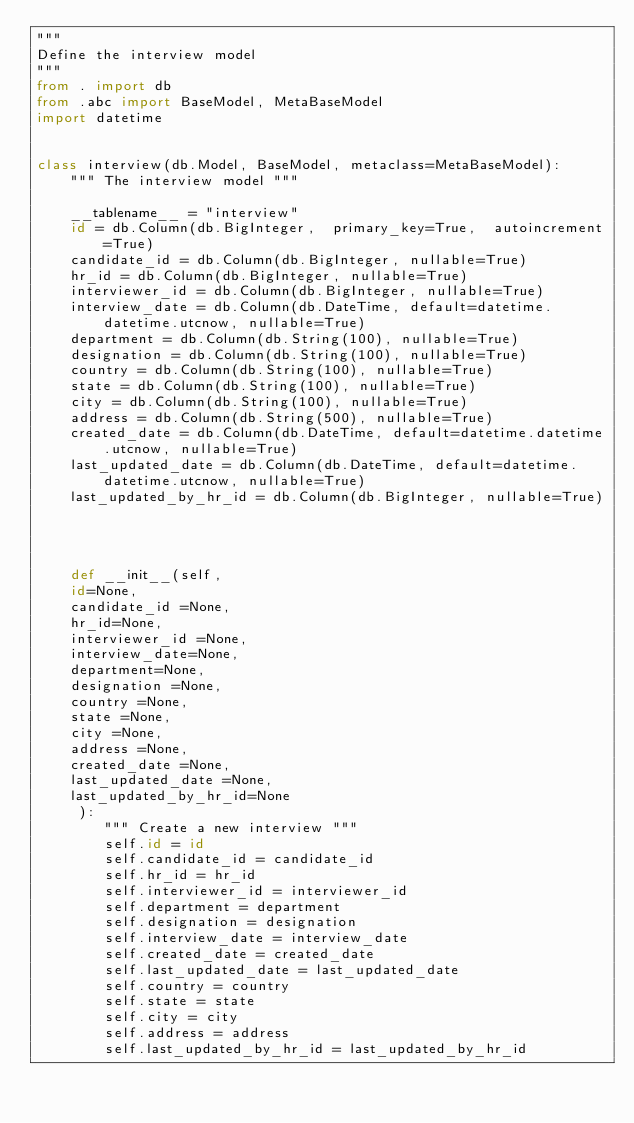Convert code to text. <code><loc_0><loc_0><loc_500><loc_500><_Python_>"""
Define the interview model
"""
from . import db
from .abc import BaseModel, MetaBaseModel
import datetime


class interview(db.Model, BaseModel, metaclass=MetaBaseModel):
    """ The interview model """

    __tablename__ = "interview"
    id = db.Column(db.BigInteger,  primary_key=True,  autoincrement=True)
    candidate_id = db.Column(db.BigInteger, nullable=True)
    hr_id = db.Column(db.BigInteger, nullable=True)
    interviewer_id = db.Column(db.BigInteger, nullable=True)
    interview_date = db.Column(db.DateTime, default=datetime.datetime.utcnow, nullable=True)
    department = db.Column(db.String(100), nullable=True)
    designation = db.Column(db.String(100), nullable=True)
    country = db.Column(db.String(100), nullable=True)
    state = db.Column(db.String(100), nullable=True)
    city = db.Column(db.String(100), nullable=True)
    address = db.Column(db.String(500), nullable=True)
    created_date = db.Column(db.DateTime, default=datetime.datetime.utcnow, nullable=True)
    last_updated_date = db.Column(db.DateTime, default=datetime.datetime.utcnow, nullable=True)
    last_updated_by_hr_id = db.Column(db.BigInteger, nullable=True)
   



    def __init__(self,
    id=None,
    candidate_id =None,
    hr_id=None,
    interviewer_id =None,
    interview_date=None,
    department=None,
    designation =None,
    country =None,
    state =None,
    city =None,
    address =None,
    created_date =None,
    last_updated_date =None,
    last_updated_by_hr_id=None
     ):
        """ Create a new interview """
        self.id = id
        self.candidate_id = candidate_id
        self.hr_id = hr_id
        self.interviewer_id = interviewer_id
        self.department = department
        self.designation = designation
        self.interview_date = interview_date
        self.created_date = created_date
        self.last_updated_date = last_updated_date
        self.country = country
        self.state = state
        self.city = city
        self.address = address
        self.last_updated_by_hr_id = last_updated_by_hr_id</code> 